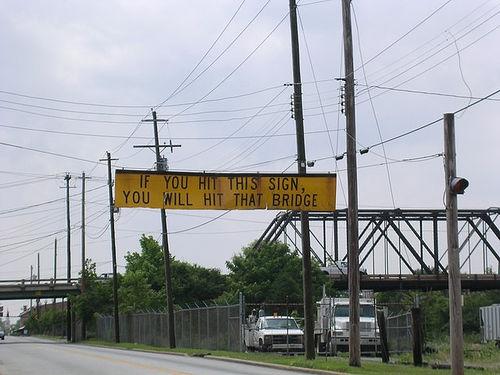What does the sign say?
Give a very brief answer. If you hit this sign you will hit that bridge. What color is the truck?
Be succinct. White. Is this in the United States of America?
Concise answer only. Yes. Is the sign and the bridge the same height?
Write a very short answer. Yes. How many cars on the road?
Write a very short answer. 1. What is the letter on the box?
Be succinct. I. 